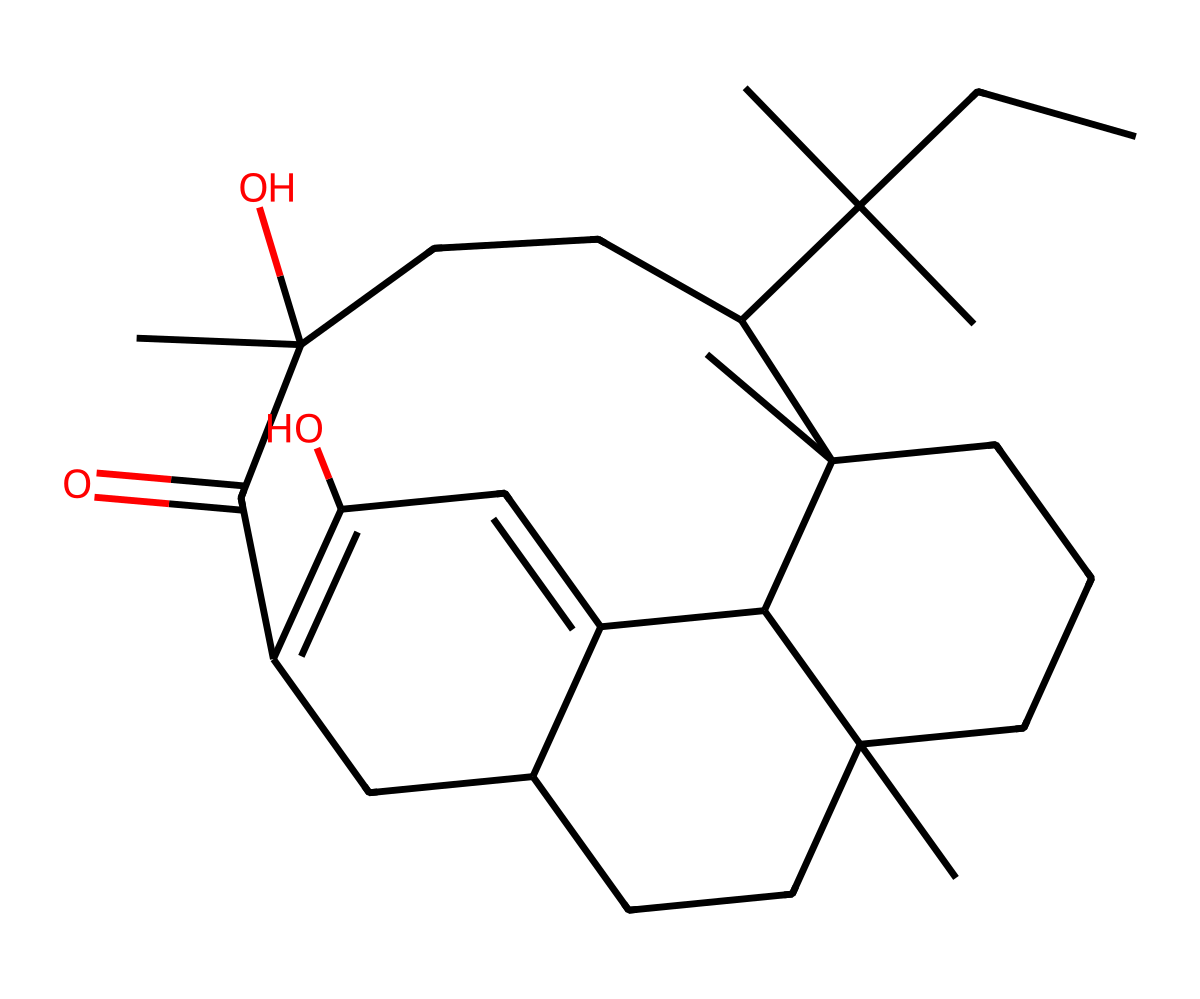What is the molecular formula of this compound? To determine the molecular formula, count the number of carbon (C), hydrogen (H), and any oxygen (O) atoms in the chemical structure. For this SMILES representation, there are 21 carbon atoms, 30 hydrogen atoms, and 2 oxygen atoms. Therefore, the molecular formula is C21H30O2.
Answer: C21H30O2 How many rings are there in the structure? Inspect the chemical structure to identify cyclic portions. The SMILES indicates multiple ring closures through the use of numbers. Counting the distinct rings, there are four rings in the structure.
Answer: four What type of functional groups are present in this molecule? Analyzing the functional groups requires identifying specific features. The molecule contains a hydroxyl group (-OH) and a carbonyl group (=O). Thus, it can be classified as containing both an alcohol and a ketone.
Answer: alcohol, ketone Is this compound saturated or unsaturated? To determine if the compound is saturated or unsaturated, one needs to assess the carbon-carbon bonds. This structure contains carbon-carbon double bonds, indicating that it is unsaturated.
Answer: unsaturated What is the primary characteristic of THC that affects its psychoactive properties? THC interacts with specific receptors in the brain, mainly due to its unique hydrocarbon structure and presence of functional groups. The rings and side chains give it the ability to bind to cannabinoid receptors.
Answer: hydrocarbon structure 